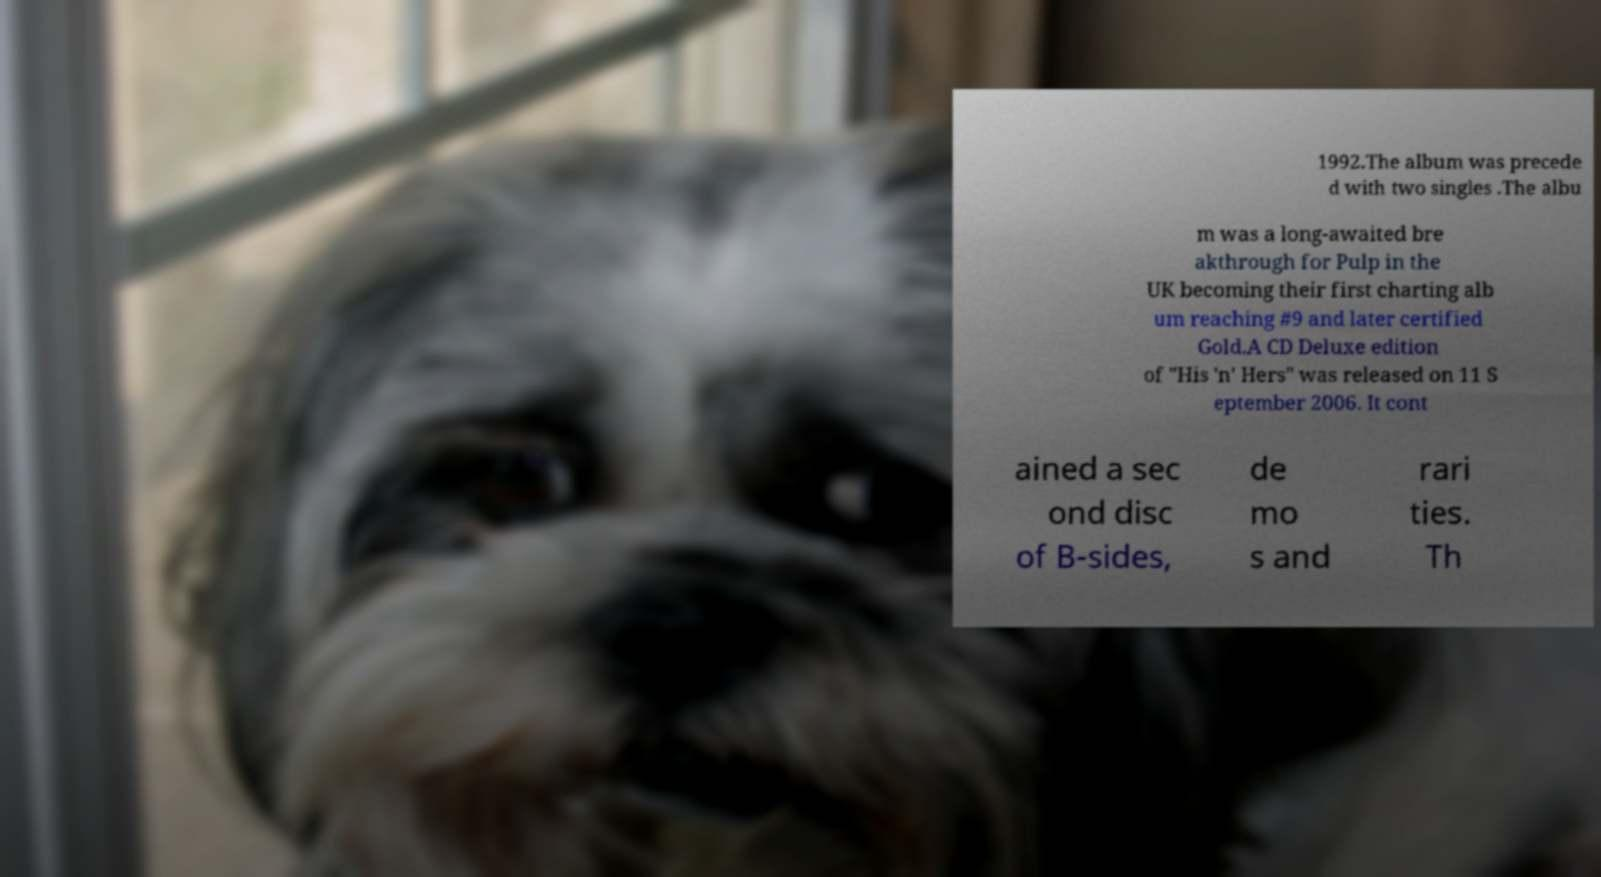For documentation purposes, I need the text within this image transcribed. Could you provide that? 1992.The album was precede d with two singles .The albu m was a long-awaited bre akthrough for Pulp in the UK becoming their first charting alb um reaching #9 and later certified Gold.A CD Deluxe edition of "His 'n' Hers" was released on 11 S eptember 2006. It cont ained a sec ond disc of B-sides, de mo s and rari ties. Th 